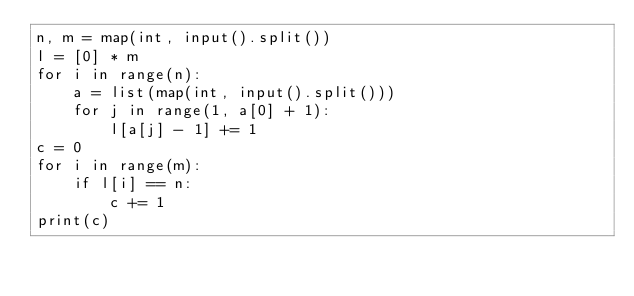<code> <loc_0><loc_0><loc_500><loc_500><_Python_>n, m = map(int, input().split())
l = [0] * m
for i in range(n):
    a = list(map(int, input().split()))
    for j in range(1, a[0] + 1):
        l[a[j] - 1] += 1
c = 0
for i in range(m):
    if l[i] == n:
        c += 1
print(c)</code> 